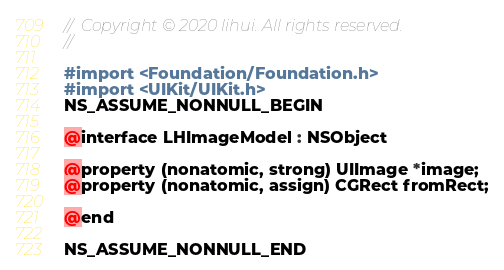Convert code to text. <code><loc_0><loc_0><loc_500><loc_500><_C_>//  Copyright © 2020 lihui. All rights reserved.
//

#import <Foundation/Foundation.h>
#import <UIKit/UIKit.h>
NS_ASSUME_NONNULL_BEGIN

@interface LHImageModel : NSObject

@property (nonatomic, strong) UIImage *image;
@property (nonatomic, assign) CGRect fromRect;

@end

NS_ASSUME_NONNULL_END
</code> 